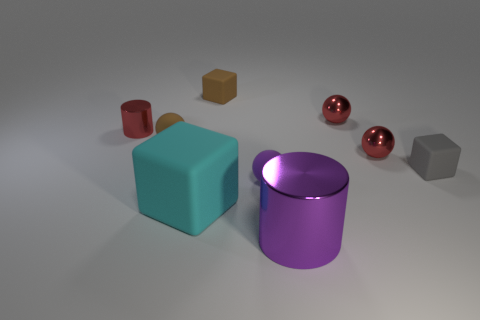There is a small block that is behind the small rubber thing that is to the right of the big cylinder; what is it made of?
Give a very brief answer. Rubber. There is a tiny rubber ball that is behind the small gray rubber object; does it have the same color as the large metallic cylinder?
Make the answer very short. No. What number of other gray rubber things are the same shape as the large matte object?
Provide a short and direct response. 1. What size is the purple cylinder that is made of the same material as the red cylinder?
Your answer should be compact. Large. Is there a cylinder that is on the right side of the tiny purple thing that is on the right side of the matte cube that is behind the gray rubber block?
Keep it short and to the point. Yes. There is a red shiny sphere in front of the red cylinder; is its size the same as the cyan block?
Provide a succinct answer. No. How many other gray matte things have the same size as the gray rubber object?
Give a very brief answer. 0. The large metallic object is what shape?
Provide a succinct answer. Cylinder. Are there any small metallic objects of the same color as the small cylinder?
Make the answer very short. Yes. Is the number of metallic cylinders that are to the left of the tiny brown block greater than the number of big yellow balls?
Offer a terse response. Yes. 